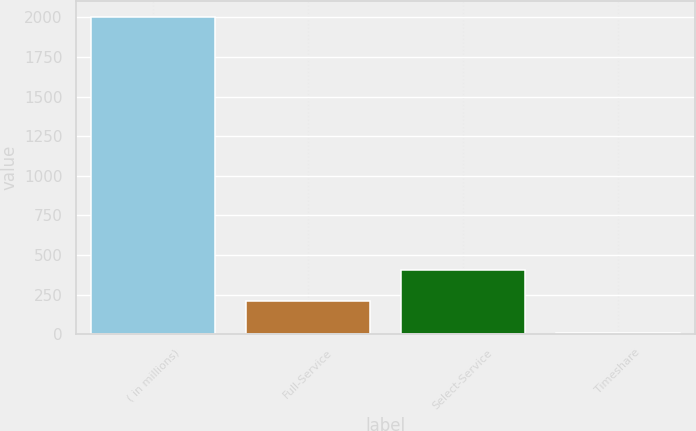<chart> <loc_0><loc_0><loc_500><loc_500><bar_chart><fcel>( in millions)<fcel>Full-Service<fcel>Select-Service<fcel>Timeshare<nl><fcel>2004<fcel>206.7<fcel>406.4<fcel>7<nl></chart> 